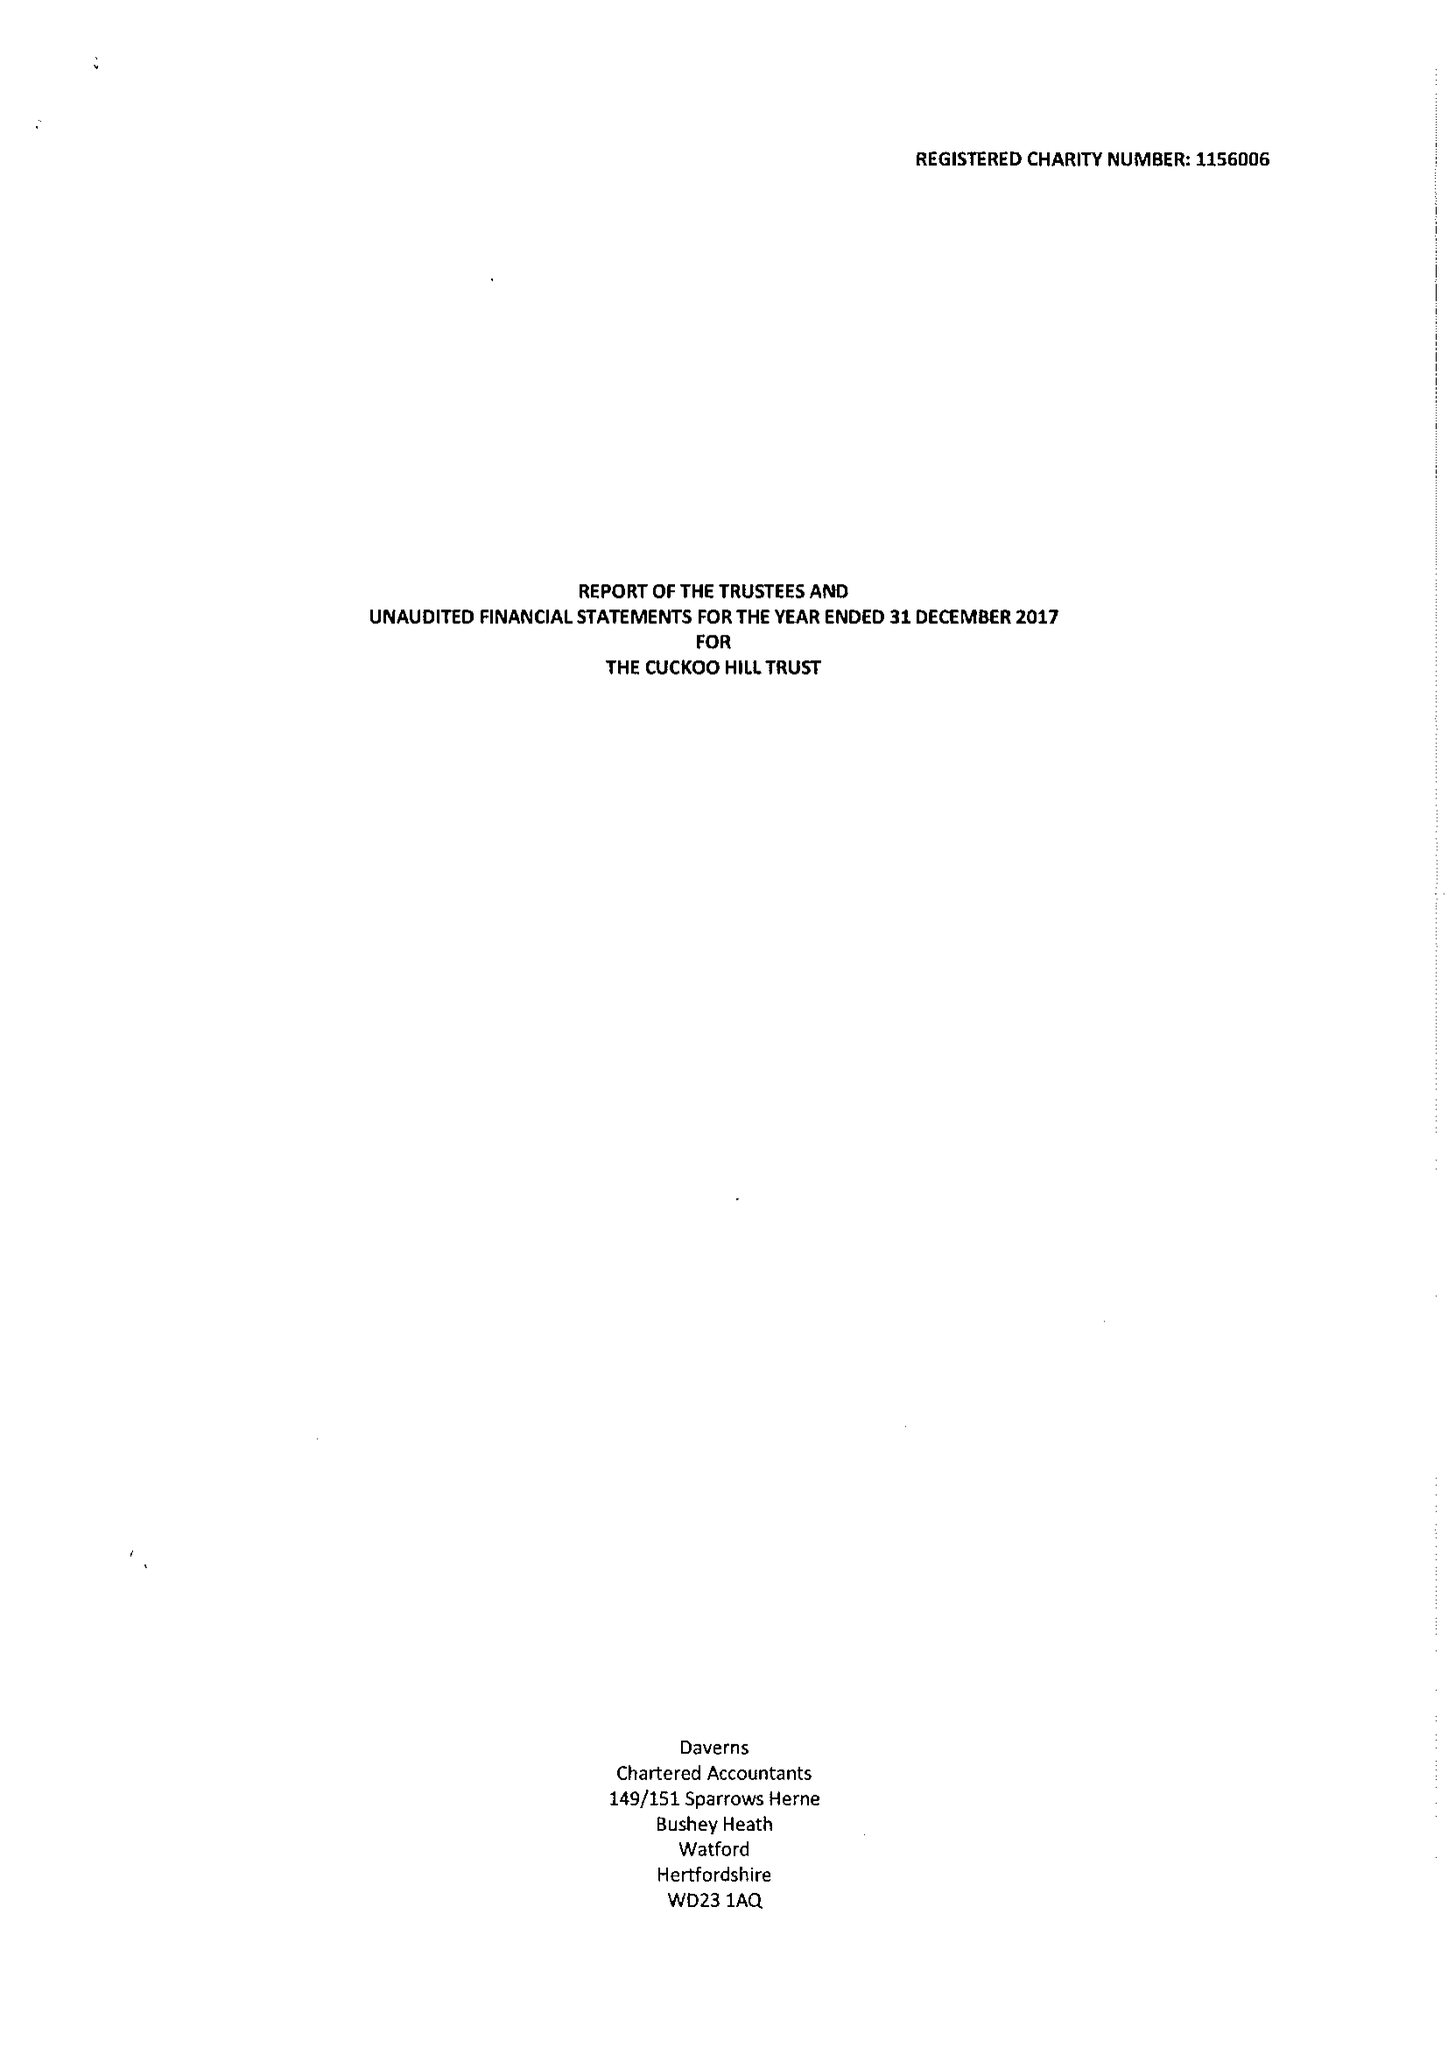What is the value for the income_annually_in_british_pounds?
Answer the question using a single word or phrase. 100000.00 